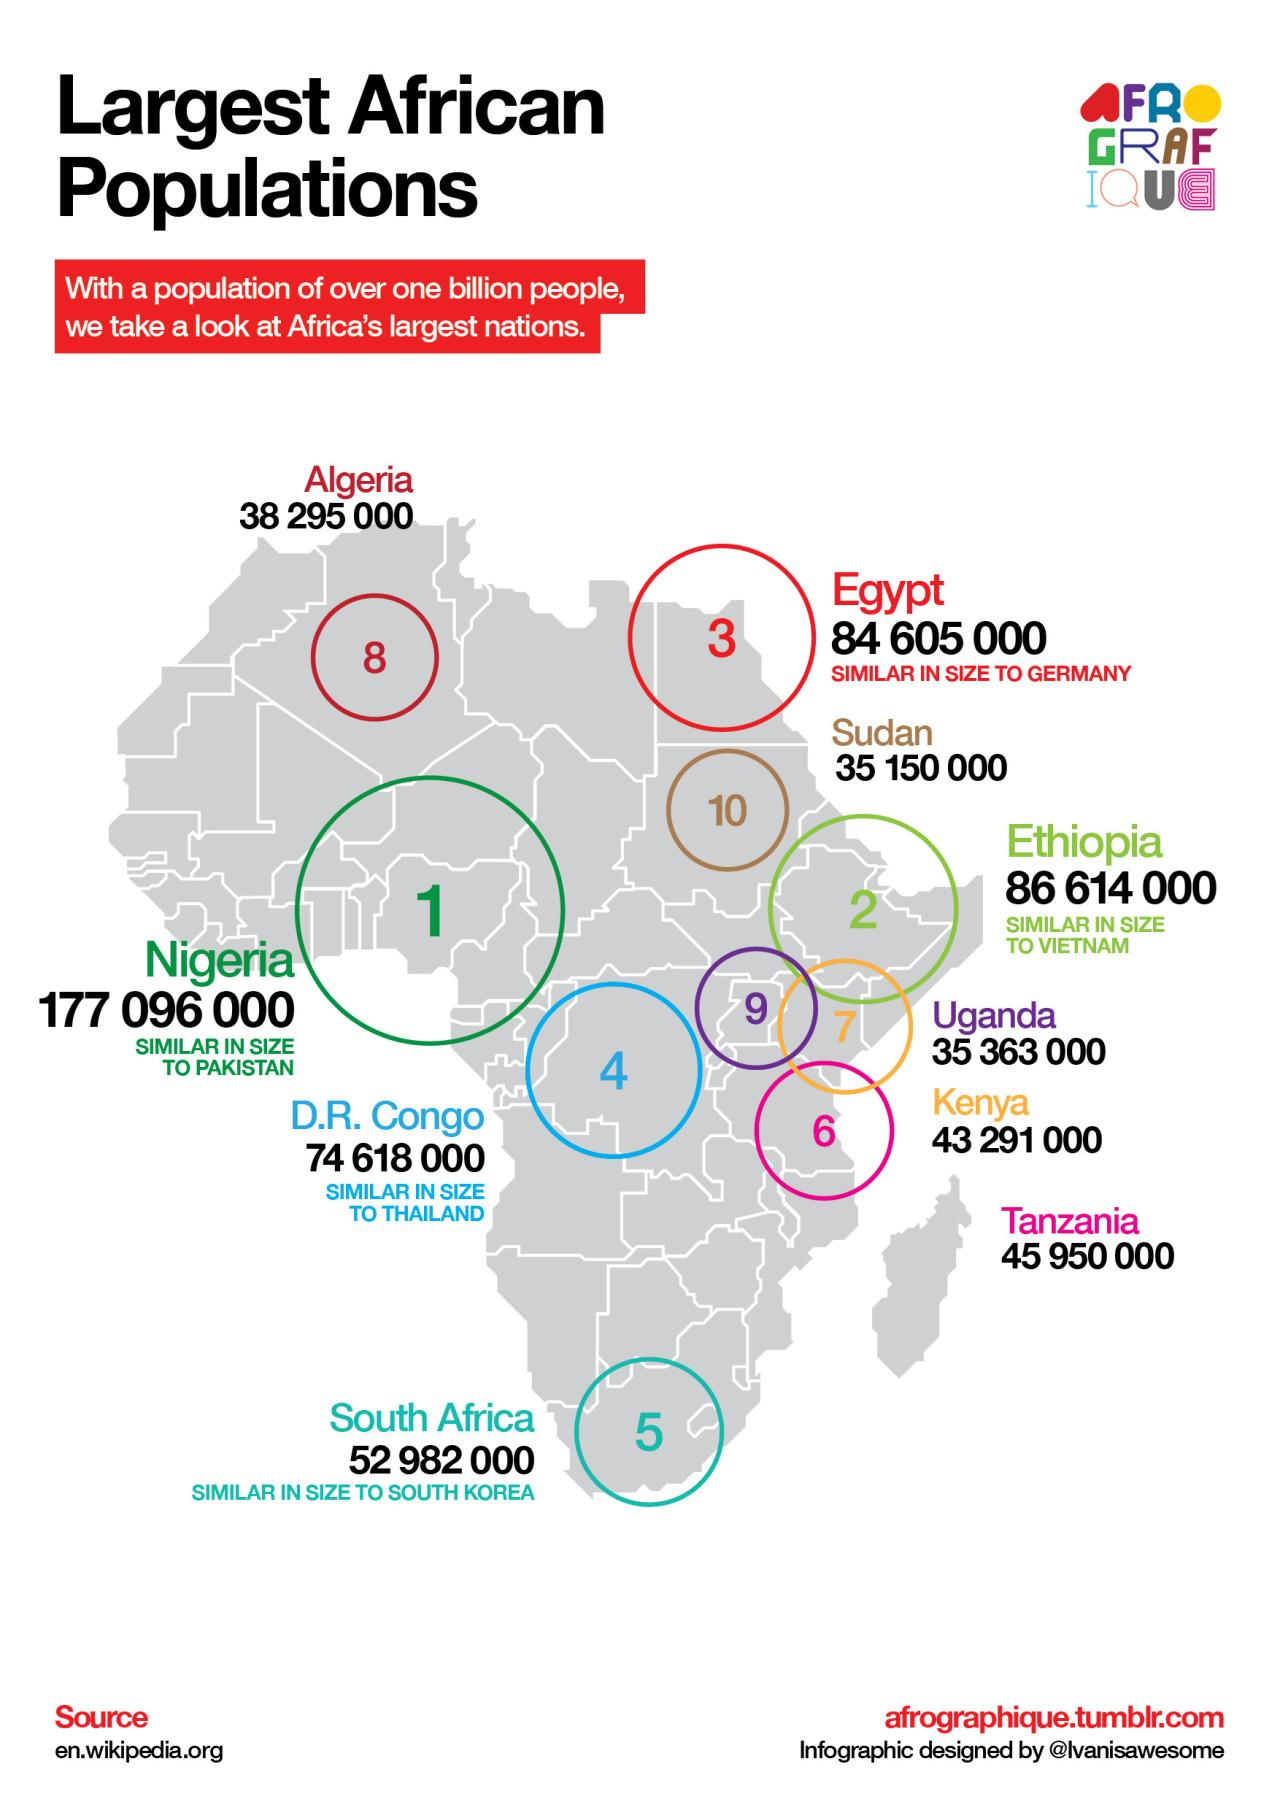Outline some significant characteristics in this image. The population of Nigeria is higher than the population of Ethiopia. The country with the largest population in Africa has a population of 177,096,000. The country with the 7th largest population in Africa has a population of 4,329,100. Tanzania is the country with the sixth largest population in Africa. The total population of South Africa and Tanzania taken together is approximately 98,932,000. 